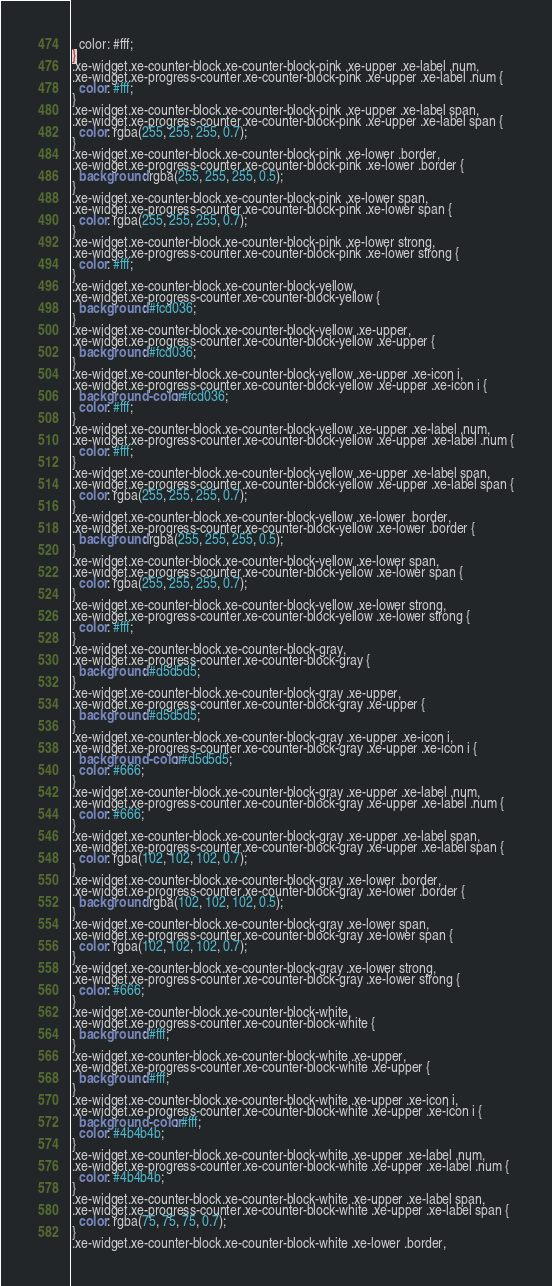<code> <loc_0><loc_0><loc_500><loc_500><_CSS_>  color: #fff;
}
.xe-widget.xe-counter-block.xe-counter-block-pink .xe-upper .xe-label .num,
.xe-widget.xe-progress-counter.xe-counter-block-pink .xe-upper .xe-label .num {
  color: #fff;
}
.xe-widget.xe-counter-block.xe-counter-block-pink .xe-upper .xe-label span,
.xe-widget.xe-progress-counter.xe-counter-block-pink .xe-upper .xe-label span {
  color: rgba(255, 255, 255, 0.7);
}
.xe-widget.xe-counter-block.xe-counter-block-pink .xe-lower .border,
.xe-widget.xe-progress-counter.xe-counter-block-pink .xe-lower .border {
  background: rgba(255, 255, 255, 0.5);
}
.xe-widget.xe-counter-block.xe-counter-block-pink .xe-lower span,
.xe-widget.xe-progress-counter.xe-counter-block-pink .xe-lower span {
  color: rgba(255, 255, 255, 0.7);
}
.xe-widget.xe-counter-block.xe-counter-block-pink .xe-lower strong,
.xe-widget.xe-progress-counter.xe-counter-block-pink .xe-lower strong {
  color: #fff;
}
.xe-widget.xe-counter-block.xe-counter-block-yellow,
.xe-widget.xe-progress-counter.xe-counter-block-yellow {
  background: #fcd036;
}
.xe-widget.xe-counter-block.xe-counter-block-yellow .xe-upper,
.xe-widget.xe-progress-counter.xe-counter-block-yellow .xe-upper {
  background: #fcd036;
}
.xe-widget.xe-counter-block.xe-counter-block-yellow .xe-upper .xe-icon i,
.xe-widget.xe-progress-counter.xe-counter-block-yellow .xe-upper .xe-icon i {
  background-color: #fcd036;
  color: #fff;
}
.xe-widget.xe-counter-block.xe-counter-block-yellow .xe-upper .xe-label .num,
.xe-widget.xe-progress-counter.xe-counter-block-yellow .xe-upper .xe-label .num {
  color: #fff;
}
.xe-widget.xe-counter-block.xe-counter-block-yellow .xe-upper .xe-label span,
.xe-widget.xe-progress-counter.xe-counter-block-yellow .xe-upper .xe-label span {
  color: rgba(255, 255, 255, 0.7);
}
.xe-widget.xe-counter-block.xe-counter-block-yellow .xe-lower .border,
.xe-widget.xe-progress-counter.xe-counter-block-yellow .xe-lower .border {
  background: rgba(255, 255, 255, 0.5);
}
.xe-widget.xe-counter-block.xe-counter-block-yellow .xe-lower span,
.xe-widget.xe-progress-counter.xe-counter-block-yellow .xe-lower span {
  color: rgba(255, 255, 255, 0.7);
}
.xe-widget.xe-counter-block.xe-counter-block-yellow .xe-lower strong,
.xe-widget.xe-progress-counter.xe-counter-block-yellow .xe-lower strong {
  color: #fff;
}
.xe-widget.xe-counter-block.xe-counter-block-gray,
.xe-widget.xe-progress-counter.xe-counter-block-gray {
  background: #d5d5d5;
}
.xe-widget.xe-counter-block.xe-counter-block-gray .xe-upper,
.xe-widget.xe-progress-counter.xe-counter-block-gray .xe-upper {
  background: #d5d5d5;
}
.xe-widget.xe-counter-block.xe-counter-block-gray .xe-upper .xe-icon i,
.xe-widget.xe-progress-counter.xe-counter-block-gray .xe-upper .xe-icon i {
  background-color: #d5d5d5;
  color: #666;
}
.xe-widget.xe-counter-block.xe-counter-block-gray .xe-upper .xe-label .num,
.xe-widget.xe-progress-counter.xe-counter-block-gray .xe-upper .xe-label .num {
  color: #666;
}
.xe-widget.xe-counter-block.xe-counter-block-gray .xe-upper .xe-label span,
.xe-widget.xe-progress-counter.xe-counter-block-gray .xe-upper .xe-label span {
  color: rgba(102, 102, 102, 0.7);
}
.xe-widget.xe-counter-block.xe-counter-block-gray .xe-lower .border,
.xe-widget.xe-progress-counter.xe-counter-block-gray .xe-lower .border {
  background: rgba(102, 102, 102, 0.5);
}
.xe-widget.xe-counter-block.xe-counter-block-gray .xe-lower span,
.xe-widget.xe-progress-counter.xe-counter-block-gray .xe-lower span {
  color: rgba(102, 102, 102, 0.7);
}
.xe-widget.xe-counter-block.xe-counter-block-gray .xe-lower strong,
.xe-widget.xe-progress-counter.xe-counter-block-gray .xe-lower strong {
  color: #666;
}
.xe-widget.xe-counter-block.xe-counter-block-white,
.xe-widget.xe-progress-counter.xe-counter-block-white {
  background: #fff;
}
.xe-widget.xe-counter-block.xe-counter-block-white .xe-upper,
.xe-widget.xe-progress-counter.xe-counter-block-white .xe-upper {
  background: #fff;
}
.xe-widget.xe-counter-block.xe-counter-block-white .xe-upper .xe-icon i,
.xe-widget.xe-progress-counter.xe-counter-block-white .xe-upper .xe-icon i {
  background-color: #fff;
  color: #4b4b4b;
}
.xe-widget.xe-counter-block.xe-counter-block-white .xe-upper .xe-label .num,
.xe-widget.xe-progress-counter.xe-counter-block-white .xe-upper .xe-label .num {
  color: #4b4b4b;
}
.xe-widget.xe-counter-block.xe-counter-block-white .xe-upper .xe-label span,
.xe-widget.xe-progress-counter.xe-counter-block-white .xe-upper .xe-label span {
  color: rgba(75, 75, 75, 0.7);
}
.xe-widget.xe-counter-block.xe-counter-block-white .xe-lower .border,</code> 